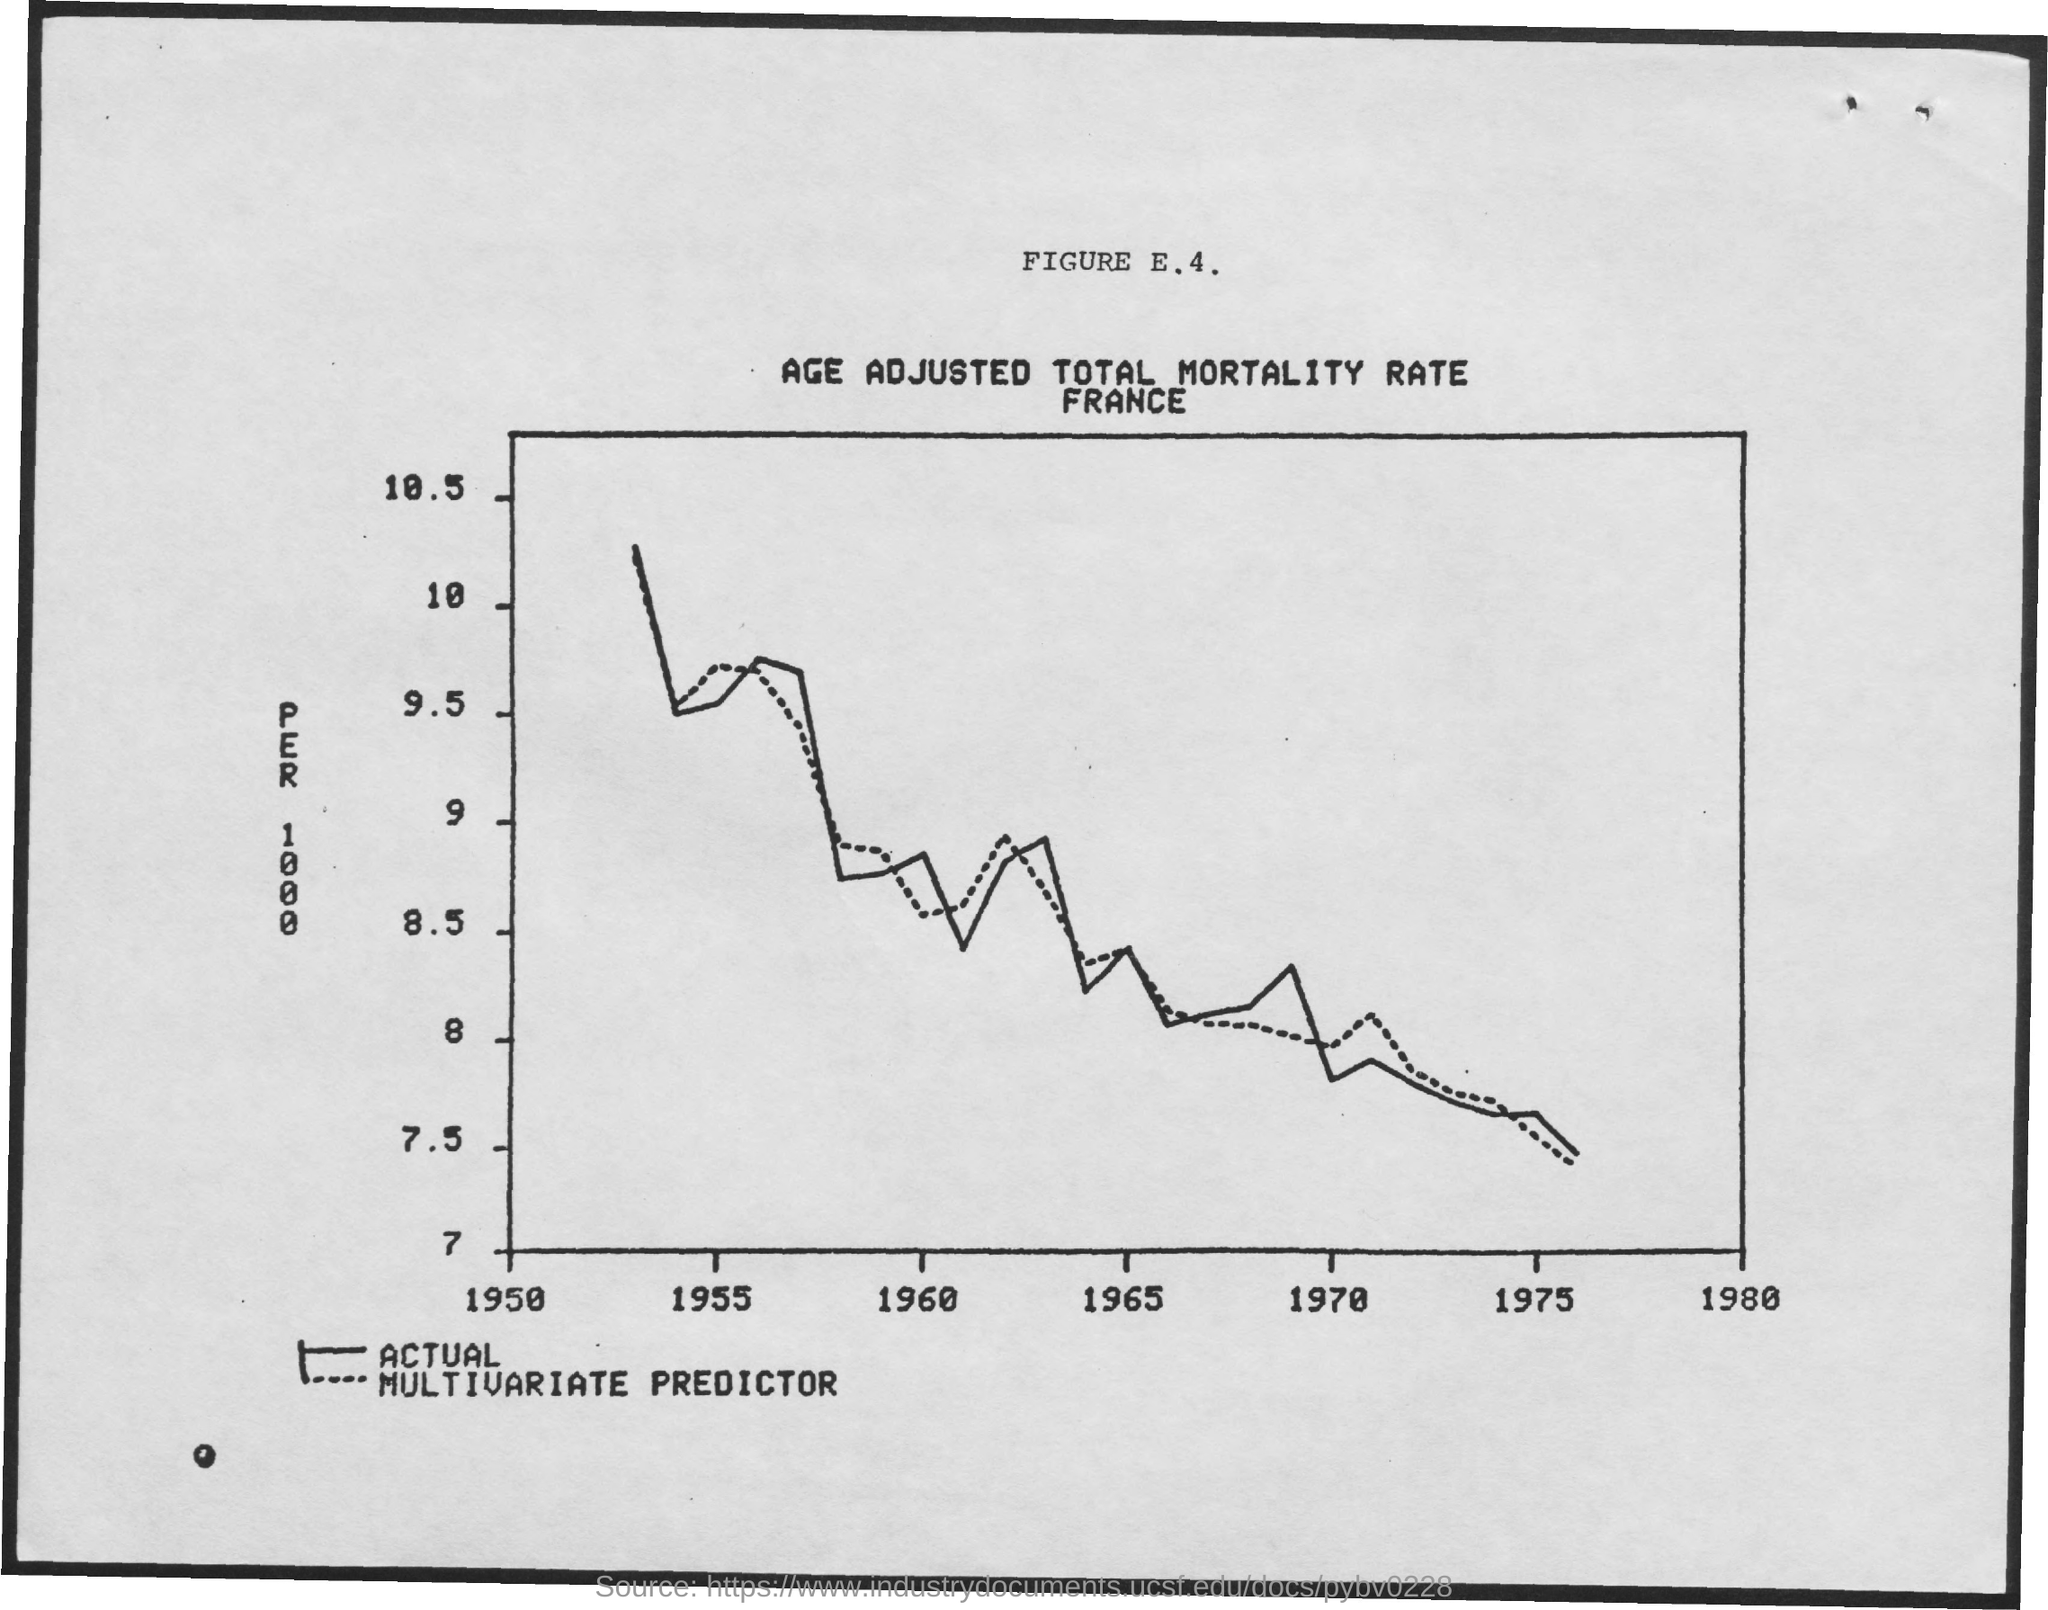Give some essential details in this illustration. The year mentioned first in the x-axis is 1950. 